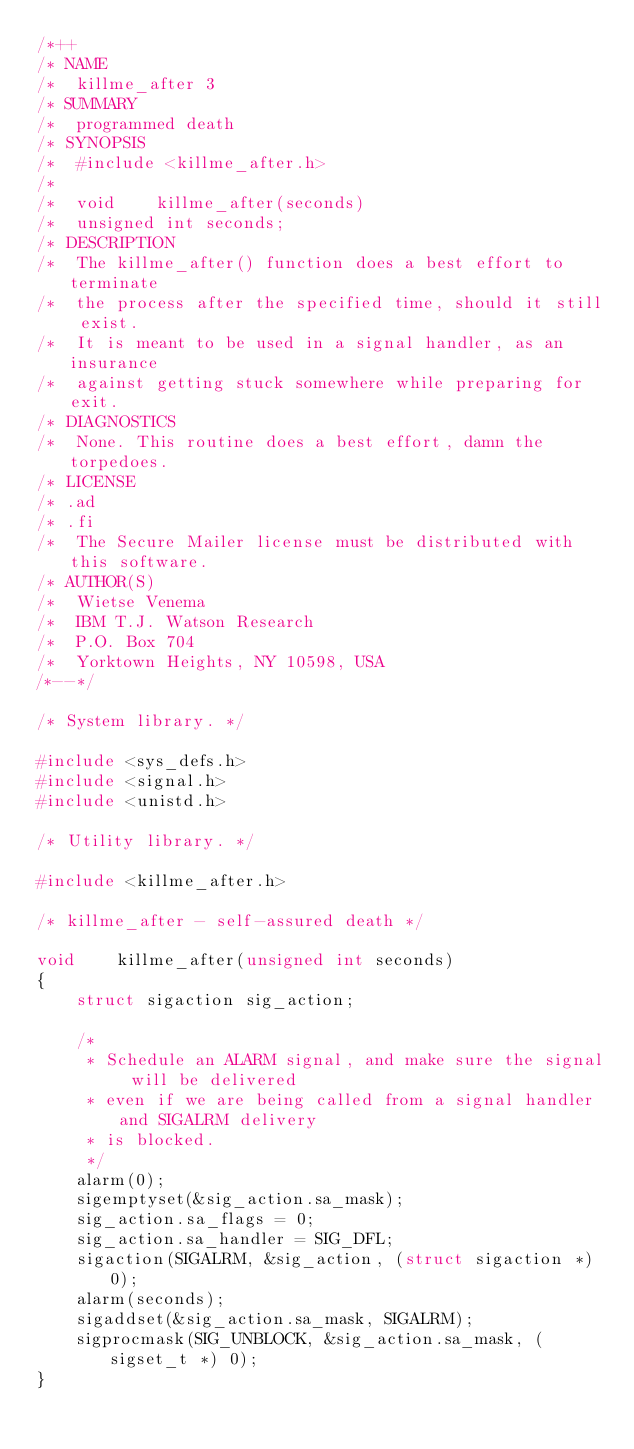<code> <loc_0><loc_0><loc_500><loc_500><_C_>/*++
/* NAME
/*	killme_after 3
/* SUMMARY
/*	programmed death
/* SYNOPSIS
/*	#include <killme_after.h>
/*
/*	void	killme_after(seconds)
/*	unsigned int seconds;
/* DESCRIPTION
/*	The killme_after() function does a best effort to terminate
/*	the process after the specified time, should it still exist.
/*	It is meant to be used in a signal handler, as an insurance
/*	against getting stuck somewhere while preparing for exit.
/* DIAGNOSTICS
/*	None. This routine does a best effort, damn the torpedoes.
/* LICENSE
/* .ad
/* .fi
/*	The Secure Mailer license must be distributed with this software.
/* AUTHOR(S)
/*	Wietse Venema
/*	IBM T.J. Watson Research
/*	P.O. Box 704
/*	Yorktown Heights, NY 10598, USA
/*--*/

/* System library. */

#include <sys_defs.h>
#include <signal.h>
#include <unistd.h>

/* Utility library. */

#include <killme_after.h>

/* killme_after - self-assured death */

void    killme_after(unsigned int seconds)
{
    struct sigaction sig_action;

    /*
     * Schedule an ALARM signal, and make sure the signal will be delivered
     * even if we are being called from a signal handler and SIGALRM delivery
     * is blocked.
     */
    alarm(0);
    sigemptyset(&sig_action.sa_mask);
    sig_action.sa_flags = 0;
    sig_action.sa_handler = SIG_DFL;
    sigaction(SIGALRM, &sig_action, (struct sigaction *) 0);
    alarm(seconds);
    sigaddset(&sig_action.sa_mask, SIGALRM);
    sigprocmask(SIG_UNBLOCK, &sig_action.sa_mask, (sigset_t *) 0);
}
</code> 